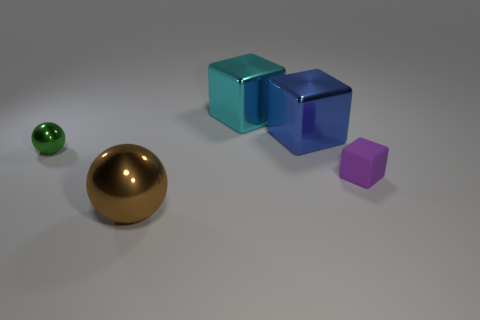Subtract all big metal blocks. How many blocks are left? 1 Subtract 1 balls. How many balls are left? 1 Subtract all green spheres. How many spheres are left? 1 Subtract all balls. How many objects are left? 3 Add 1 green balls. How many green balls are left? 2 Add 5 red things. How many red things exist? 5 Add 2 small blue metallic balls. How many objects exist? 7 Subtract 0 brown cylinders. How many objects are left? 5 Subtract all brown cubes. Subtract all blue cylinders. How many cubes are left? 3 Subtract all yellow cylinders. How many blue balls are left? 0 